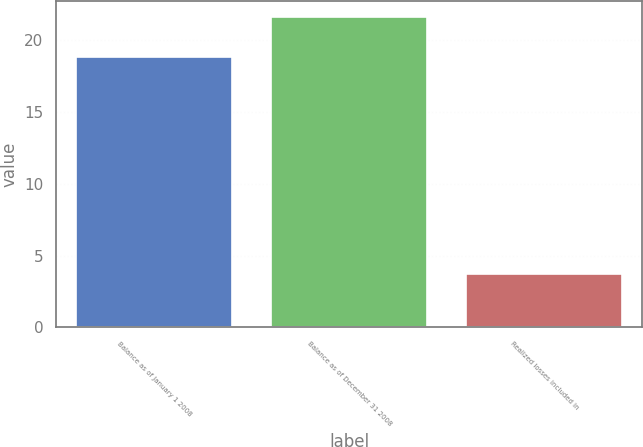Convert chart. <chart><loc_0><loc_0><loc_500><loc_500><bar_chart><fcel>Balance as of January 1 2008<fcel>Balance as of December 31 2008<fcel>Realized losses included in<nl><fcel>18.8<fcel>21.6<fcel>3.7<nl></chart> 